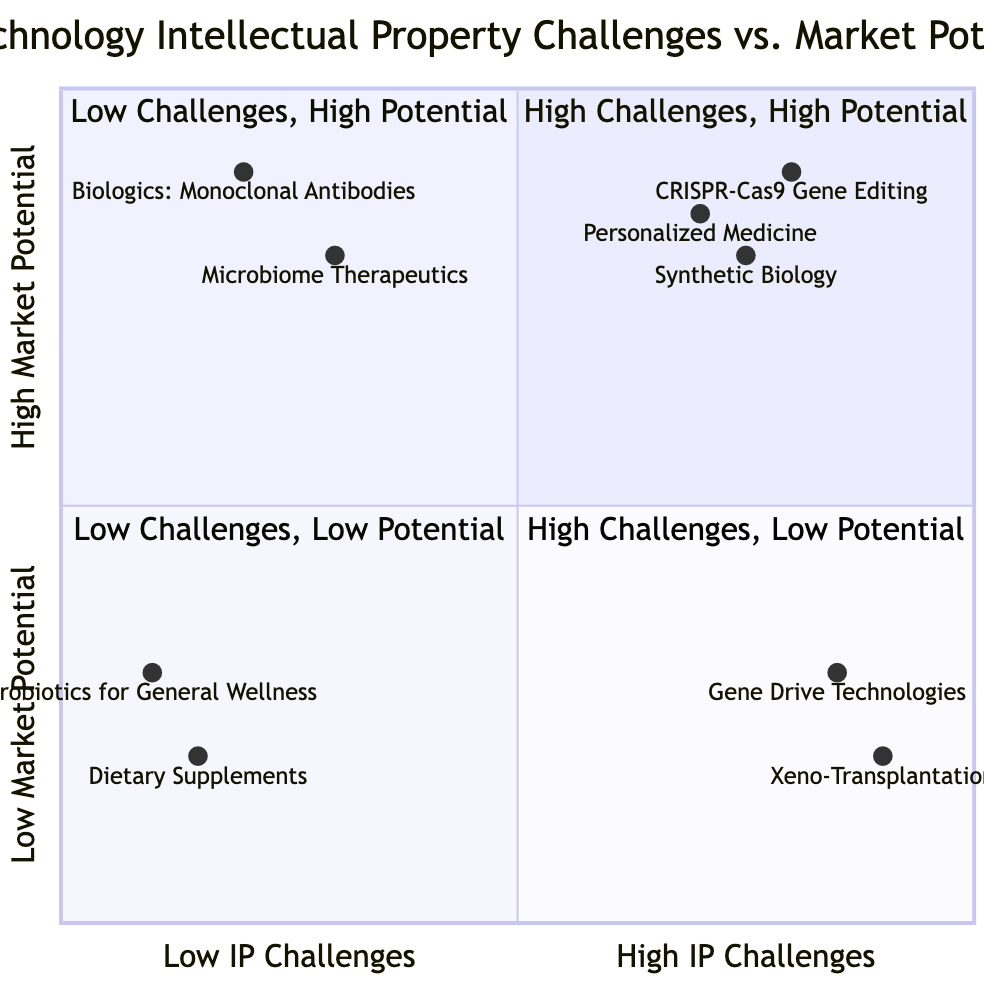What technologies are placed in the high challenges, high potential quadrant? The high challenges, high potential quadrant contains CRISPR-Cas9 Gene Editing, Personalized Medicine, and Synthetic Biology.
Answer: CRISPR-Cas9 Gene Editing, Personalized Medicine, Synthetic Biology How many technologies are in the low challenges, high potential quadrant? The low challenges, high potential quadrant lists Biologics: Monoclonal Antibodies and Microbiome Therapeutics, totaling two technologies.
Answer: 2 Which technology has the highest market potential according to the diagram? Analyzing the y-axis shows that Biologics: Monoclonal Antibodies has the highest value at 0.9.
Answer: Biologics: Monoclonal Antibodies What is the market potential of Xeno-Transplantation? The y-coordinate for Xeno-Transplantation is 0.2, which indicates its market potential.
Answer: 0.2 Which quadrants contain technologies that face high intellectual property challenges? The high challenges quadrants (high challenges, high potential and high challenges, low potential) include CRISPR-Cas9 Gene Editing, Personalized Medicine, Synthetic Biology, Gene Drive Technologies, and Xeno-Transplantation.
Answer: Two quadrants In which quadrant would you classify Probiotics for General Wellness? Probiotics for General Wellness falls into the low challenges, low potential quadrant as indicated by its coordinates.
Answer: Low Challenges, Low Potential What other technology appears in the same quadrant as Microbiome Therapeutics? Microbiome Therapeutics is in the low challenges, high potential quadrant along with Biologics: Monoclonal Antibodies.
Answer: Biologics: Monoclonal Antibodies Which technology explains a low market potential in comparison to its intellectual property challenges? Gene Drive Technologies is a prime example, having high challenges but lower market potential at 0.3.
Answer: Gene Drive Technologies How many technologies are categorized under low challenges, low potential? There are two technologies, Probiotics for General Wellness and Dietary Supplements, in the low challenges, low potential quadrant.
Answer: 2 